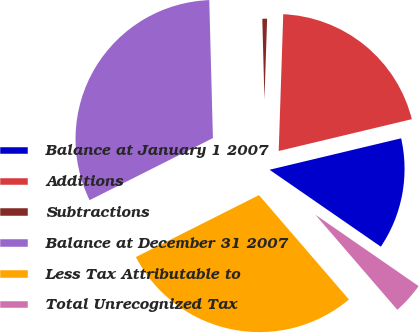<chart> <loc_0><loc_0><loc_500><loc_500><pie_chart><fcel>Balance at January 1 2007<fcel>Additions<fcel>Subtractions<fcel>Balance at December 31 2007<fcel>Less Tax Attributable to<fcel>Total Unrecognized Tax<nl><fcel>13.36%<fcel>20.74%<fcel>0.95%<fcel>32.0%<fcel>28.9%<fcel>4.05%<nl></chart> 